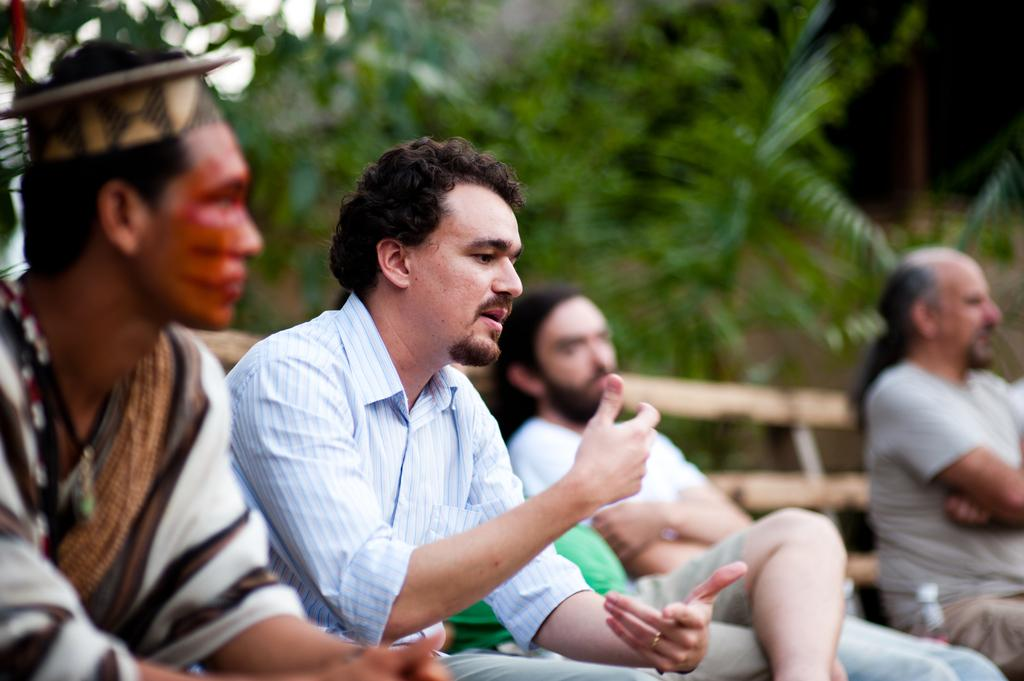What are the people in the image doing? The people in the image are sitting on a bench. What else can be seen in the image besides the people on the bench? There are bottles visible in the image. Can you describe the background of the image? The background of the image is blurry, and leaves are present. What color is the crayon being used by the person sitting on the bench in the image? There is no crayon present in the image. Is there a baseball game happening in the background of the image? There is no baseball game or any reference to baseball in the image. 